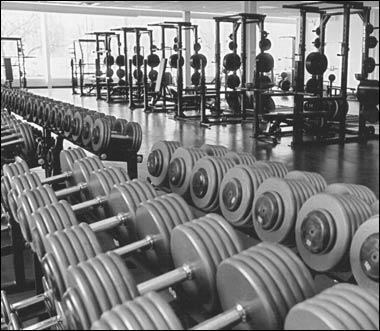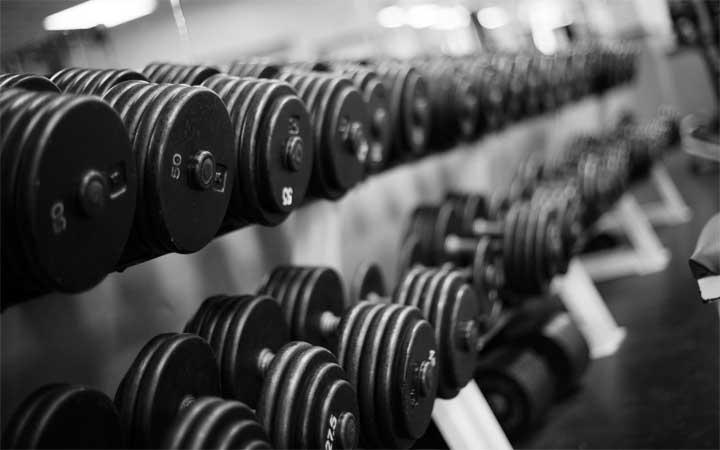The first image is the image on the left, the second image is the image on the right. Analyze the images presented: Is the assertion "The round weights are sitting on the floor in one of the images." valid? Answer yes or no. No. The first image is the image on the left, the second image is the image on the right. For the images displayed, is the sentence "The dumbbells closest to the camera in one image have beveled edges instead of round edges." factually correct? Answer yes or no. No. 